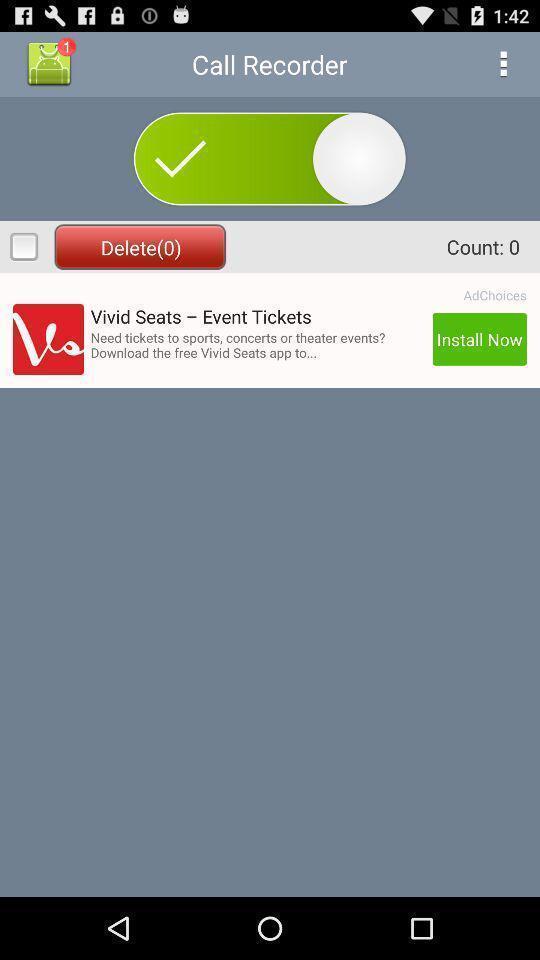What is the overall content of this screenshot? Page for recording calls of a recording app. 